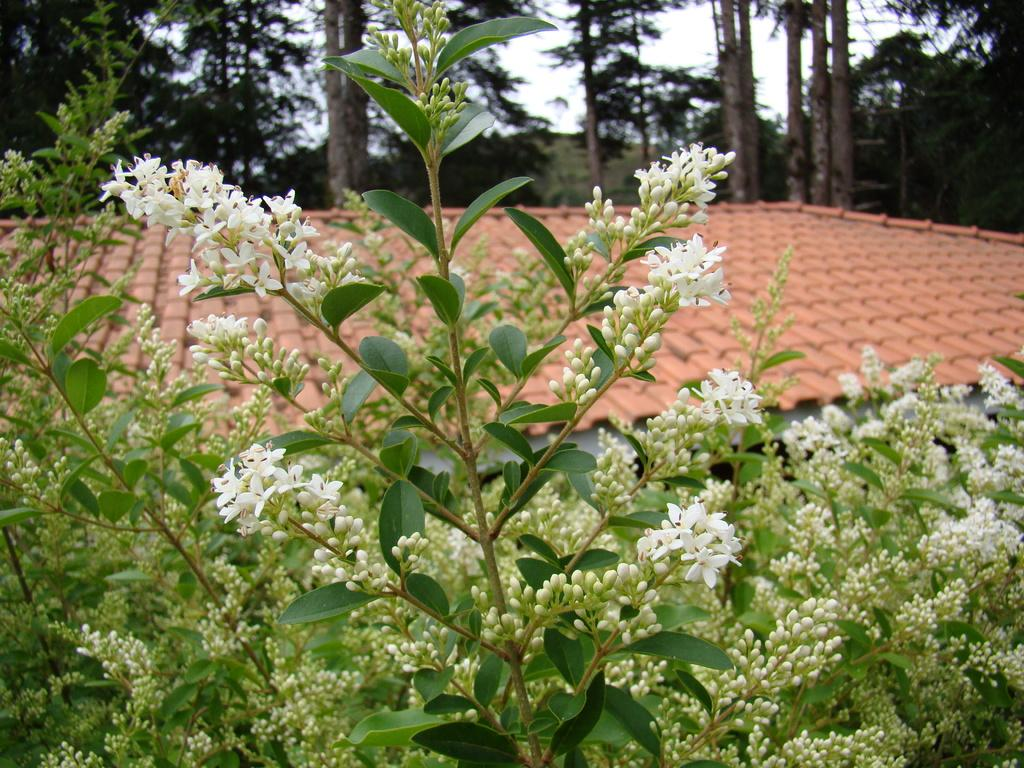What type of vegetation can be seen in the image? There are plants, flowers, and trees in the image. What type of structure is present in the image? There is a house in the image. What is visible in the background of the image? The sky is visible in the image. Can you tell me how many cabbages are in the image? There are no cabbages present in the image. What type of sport is being played in the image? There is no sport being played in the image; it features plants, flowers, trees, a house, and the sky. 